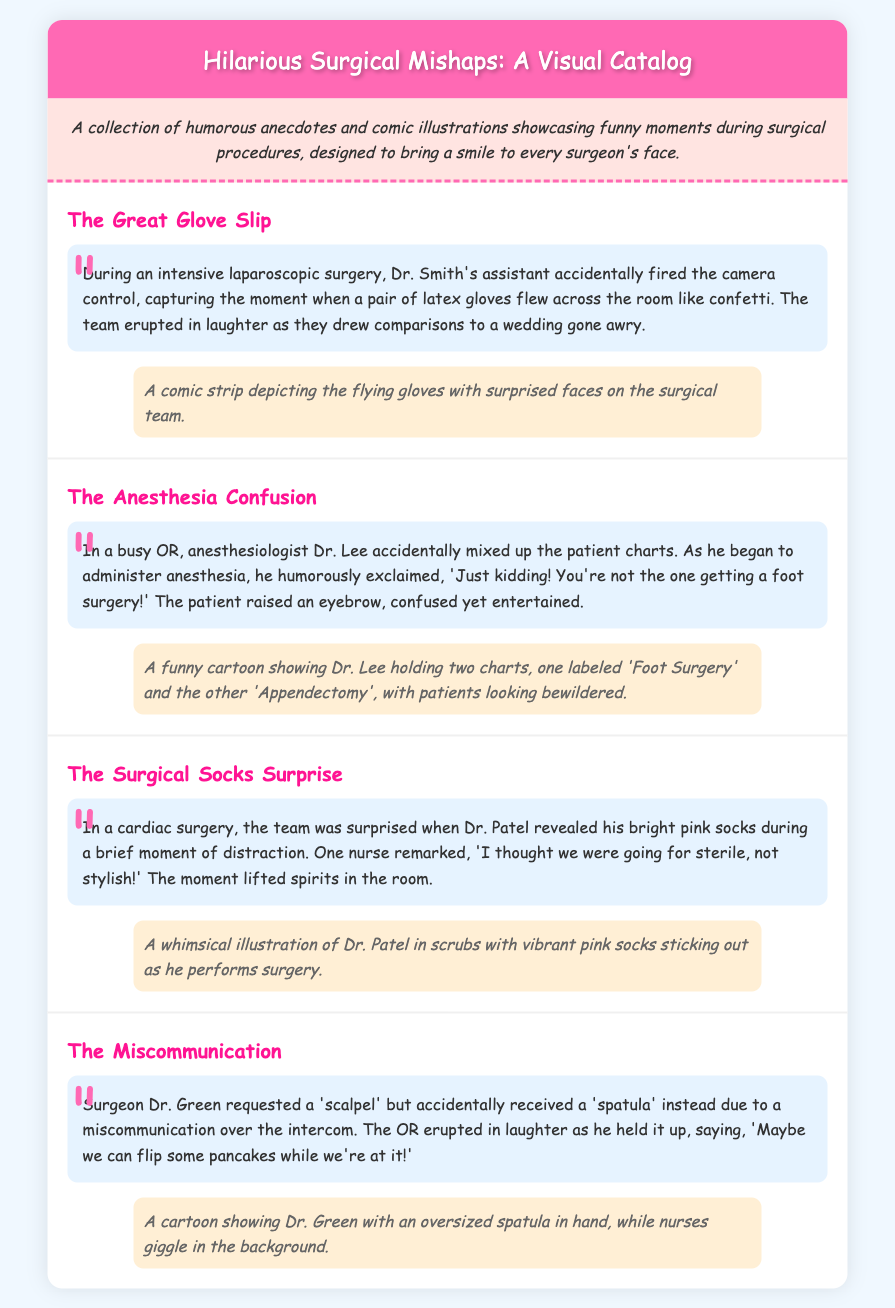what is the title of the document? The title is located in the header section and refers to the main subject matter.
Answer: Hilarious Surgical Mishaps: A Visual Catalog who is the surgeon mentioned in the "Surgical Socks Surprise"? The anecdote specifically mentions the name of the surgeon associated with this mishap.
Answer: Dr. Patel what color were Dr. Patel's socks? The description clearly states the color of the socks revealed during the surgery.
Answer: pink how many surgical mishaps are described in the catalog? The number of mishaps can be counted based on the distinct sections in the document.
Answer: four what humorous remark did Dr. Green make during the "Miscommunication"? The anecdote provides a quote from Dr. Green that illustrates the humor of the situation.
Answer: "Maybe we can flip some pancakes while we're at it!" what did Dr. Lee humorously say when he mixed up the charts? The statement made by Dr. Lee during the anesthesia confusion incident highlights his light-hearted approach.
Answer: "Just kidding! You're not the one getting a foot surgery!" which surgical incident involved a camera control mistake? The mishap that mentions the shooting of latex gloves relates to a specific surgical procedure.
Answer: The Great Glove Slip what illustration describes the "Anesthesia Confusion"? The illustration for this incident features a specific depiction related to Dr. Lee's actions.
Answer: A funny cartoon showing Dr. Lee holding two charts 